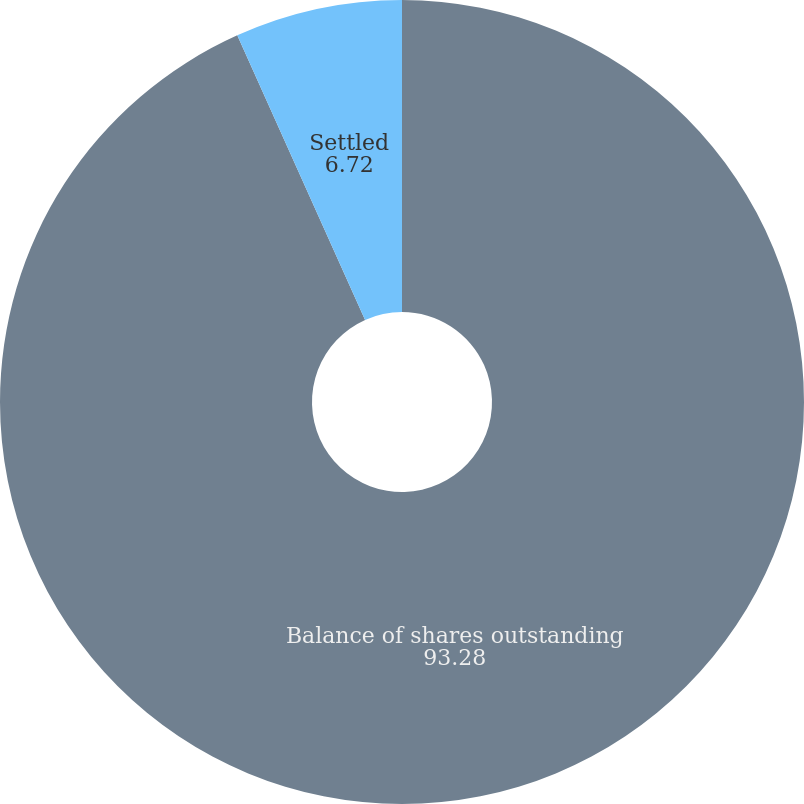Convert chart. <chart><loc_0><loc_0><loc_500><loc_500><pie_chart><fcel>Balance of shares outstanding<fcel>Settled<nl><fcel>93.28%<fcel>6.72%<nl></chart> 